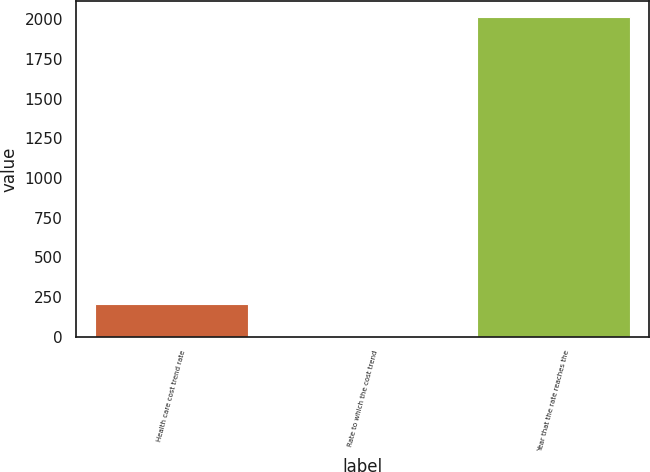Convert chart. <chart><loc_0><loc_0><loc_500><loc_500><bar_chart><fcel>Health care cost trend rate<fcel>Rate to which the cost trend<fcel>Year that the rate reaches the<nl><fcel>205.8<fcel>5<fcel>2013<nl></chart> 